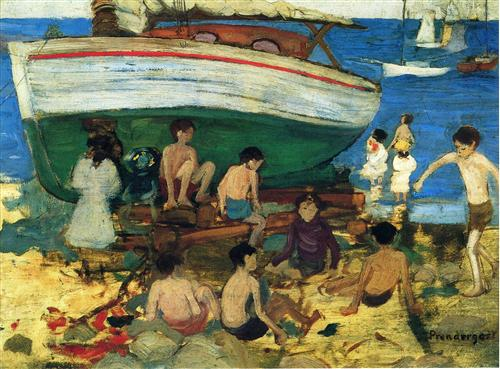What's happening in the scene? The image depicts a picturesque seaside scene, vividly rendered in impressionist style. There are several people engaged in varying activities, suggesting a leisurely day at the beach. Prominently, some are seen conversing, others are gazing at the sea, and children are playing on the sand, all beneath a luminous sky. The vibrant colors used, especially in depicting the sand, sea, and the sky, capture the essence of a warm, sunny day. In the background, a distinctive large boat with a faded red roof offers a rustic charm, anchoring the scene visually and thematically. This painting not only showcases a day of leisure but also highlights the beauty and casual interaction of daily life by the sea. 